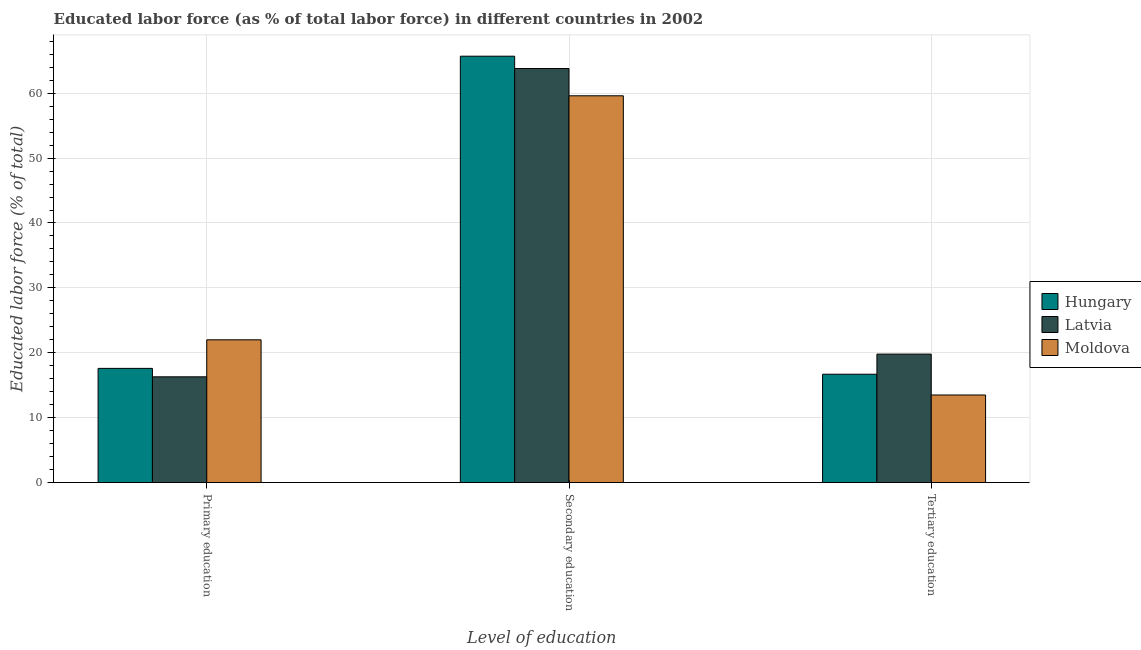Are the number of bars on each tick of the X-axis equal?
Ensure brevity in your answer.  Yes. How many bars are there on the 1st tick from the left?
Ensure brevity in your answer.  3. How many bars are there on the 1st tick from the right?
Ensure brevity in your answer.  3. What is the label of the 1st group of bars from the left?
Ensure brevity in your answer.  Primary education. What is the percentage of labor force who received primary education in Hungary?
Provide a short and direct response. 17.6. Across all countries, what is the maximum percentage of labor force who received secondary education?
Provide a short and direct response. 65.7. Across all countries, what is the minimum percentage of labor force who received secondary education?
Your answer should be very brief. 59.6. In which country was the percentage of labor force who received primary education maximum?
Keep it short and to the point. Moldova. In which country was the percentage of labor force who received primary education minimum?
Offer a very short reply. Latvia. What is the total percentage of labor force who received primary education in the graph?
Provide a succinct answer. 55.9. What is the difference between the percentage of labor force who received secondary education in Latvia and that in Hungary?
Offer a very short reply. -1.9. What is the difference between the percentage of labor force who received secondary education in Latvia and the percentage of labor force who received primary education in Moldova?
Give a very brief answer. 41.8. What is the average percentage of labor force who received primary education per country?
Your answer should be very brief. 18.63. What is the difference between the percentage of labor force who received primary education and percentage of labor force who received secondary education in Hungary?
Provide a short and direct response. -48.1. What is the ratio of the percentage of labor force who received secondary education in Hungary to that in Latvia?
Provide a short and direct response. 1.03. Is the percentage of labor force who received secondary education in Latvia less than that in Hungary?
Offer a terse response. Yes. What is the difference between the highest and the second highest percentage of labor force who received tertiary education?
Your response must be concise. 3.1. What is the difference between the highest and the lowest percentage of labor force who received tertiary education?
Give a very brief answer. 6.3. In how many countries, is the percentage of labor force who received secondary education greater than the average percentage of labor force who received secondary education taken over all countries?
Make the answer very short. 2. What does the 1st bar from the left in Tertiary education represents?
Offer a terse response. Hungary. What does the 1st bar from the right in Secondary education represents?
Make the answer very short. Moldova. How many bars are there?
Provide a succinct answer. 9. Are all the bars in the graph horizontal?
Your answer should be very brief. No. What is the difference between two consecutive major ticks on the Y-axis?
Make the answer very short. 10. Does the graph contain any zero values?
Your answer should be very brief. No. Where does the legend appear in the graph?
Your answer should be very brief. Center right. How are the legend labels stacked?
Your response must be concise. Vertical. What is the title of the graph?
Offer a terse response. Educated labor force (as % of total labor force) in different countries in 2002. Does "Japan" appear as one of the legend labels in the graph?
Your answer should be compact. No. What is the label or title of the X-axis?
Ensure brevity in your answer.  Level of education. What is the label or title of the Y-axis?
Ensure brevity in your answer.  Educated labor force (% of total). What is the Educated labor force (% of total) of Hungary in Primary education?
Offer a very short reply. 17.6. What is the Educated labor force (% of total) in Latvia in Primary education?
Your response must be concise. 16.3. What is the Educated labor force (% of total) in Hungary in Secondary education?
Offer a terse response. 65.7. What is the Educated labor force (% of total) in Latvia in Secondary education?
Your answer should be compact. 63.8. What is the Educated labor force (% of total) in Moldova in Secondary education?
Keep it short and to the point. 59.6. What is the Educated labor force (% of total) in Hungary in Tertiary education?
Offer a terse response. 16.7. What is the Educated labor force (% of total) in Latvia in Tertiary education?
Provide a succinct answer. 19.8. Across all Level of education, what is the maximum Educated labor force (% of total) in Hungary?
Provide a succinct answer. 65.7. Across all Level of education, what is the maximum Educated labor force (% of total) of Latvia?
Your response must be concise. 63.8. Across all Level of education, what is the maximum Educated labor force (% of total) in Moldova?
Ensure brevity in your answer.  59.6. Across all Level of education, what is the minimum Educated labor force (% of total) of Hungary?
Your answer should be compact. 16.7. Across all Level of education, what is the minimum Educated labor force (% of total) of Latvia?
Provide a short and direct response. 16.3. Across all Level of education, what is the minimum Educated labor force (% of total) of Moldova?
Offer a very short reply. 13.5. What is the total Educated labor force (% of total) in Hungary in the graph?
Your response must be concise. 100. What is the total Educated labor force (% of total) in Latvia in the graph?
Your response must be concise. 99.9. What is the total Educated labor force (% of total) in Moldova in the graph?
Provide a succinct answer. 95.1. What is the difference between the Educated labor force (% of total) of Hungary in Primary education and that in Secondary education?
Your response must be concise. -48.1. What is the difference between the Educated labor force (% of total) in Latvia in Primary education and that in Secondary education?
Your answer should be very brief. -47.5. What is the difference between the Educated labor force (% of total) in Moldova in Primary education and that in Secondary education?
Provide a succinct answer. -37.6. What is the difference between the Educated labor force (% of total) of Moldova in Primary education and that in Tertiary education?
Provide a short and direct response. 8.5. What is the difference between the Educated labor force (% of total) in Moldova in Secondary education and that in Tertiary education?
Provide a short and direct response. 46.1. What is the difference between the Educated labor force (% of total) in Hungary in Primary education and the Educated labor force (% of total) in Latvia in Secondary education?
Your response must be concise. -46.2. What is the difference between the Educated labor force (% of total) in Hungary in Primary education and the Educated labor force (% of total) in Moldova in Secondary education?
Make the answer very short. -42. What is the difference between the Educated labor force (% of total) of Latvia in Primary education and the Educated labor force (% of total) of Moldova in Secondary education?
Give a very brief answer. -43.3. What is the difference between the Educated labor force (% of total) of Hungary in Primary education and the Educated labor force (% of total) of Moldova in Tertiary education?
Ensure brevity in your answer.  4.1. What is the difference between the Educated labor force (% of total) of Latvia in Primary education and the Educated labor force (% of total) of Moldova in Tertiary education?
Your response must be concise. 2.8. What is the difference between the Educated labor force (% of total) of Hungary in Secondary education and the Educated labor force (% of total) of Latvia in Tertiary education?
Offer a terse response. 45.9. What is the difference between the Educated labor force (% of total) in Hungary in Secondary education and the Educated labor force (% of total) in Moldova in Tertiary education?
Offer a terse response. 52.2. What is the difference between the Educated labor force (% of total) of Latvia in Secondary education and the Educated labor force (% of total) of Moldova in Tertiary education?
Give a very brief answer. 50.3. What is the average Educated labor force (% of total) of Hungary per Level of education?
Provide a short and direct response. 33.33. What is the average Educated labor force (% of total) of Latvia per Level of education?
Your answer should be very brief. 33.3. What is the average Educated labor force (% of total) in Moldova per Level of education?
Give a very brief answer. 31.7. What is the difference between the Educated labor force (% of total) in Hungary and Educated labor force (% of total) in Moldova in Primary education?
Your answer should be compact. -4.4. What is the difference between the Educated labor force (% of total) in Latvia and Educated labor force (% of total) in Moldova in Primary education?
Provide a short and direct response. -5.7. What is the difference between the Educated labor force (% of total) in Hungary and Educated labor force (% of total) in Moldova in Secondary education?
Your answer should be very brief. 6.1. What is the difference between the Educated labor force (% of total) in Latvia and Educated labor force (% of total) in Moldova in Secondary education?
Keep it short and to the point. 4.2. What is the difference between the Educated labor force (% of total) of Hungary and Educated labor force (% of total) of Moldova in Tertiary education?
Your response must be concise. 3.2. What is the difference between the Educated labor force (% of total) of Latvia and Educated labor force (% of total) of Moldova in Tertiary education?
Provide a short and direct response. 6.3. What is the ratio of the Educated labor force (% of total) in Hungary in Primary education to that in Secondary education?
Offer a very short reply. 0.27. What is the ratio of the Educated labor force (% of total) of Latvia in Primary education to that in Secondary education?
Keep it short and to the point. 0.26. What is the ratio of the Educated labor force (% of total) of Moldova in Primary education to that in Secondary education?
Offer a very short reply. 0.37. What is the ratio of the Educated labor force (% of total) of Hungary in Primary education to that in Tertiary education?
Offer a terse response. 1.05. What is the ratio of the Educated labor force (% of total) in Latvia in Primary education to that in Tertiary education?
Offer a terse response. 0.82. What is the ratio of the Educated labor force (% of total) of Moldova in Primary education to that in Tertiary education?
Your response must be concise. 1.63. What is the ratio of the Educated labor force (% of total) of Hungary in Secondary education to that in Tertiary education?
Keep it short and to the point. 3.93. What is the ratio of the Educated labor force (% of total) in Latvia in Secondary education to that in Tertiary education?
Make the answer very short. 3.22. What is the ratio of the Educated labor force (% of total) in Moldova in Secondary education to that in Tertiary education?
Your response must be concise. 4.41. What is the difference between the highest and the second highest Educated labor force (% of total) in Hungary?
Offer a terse response. 48.1. What is the difference between the highest and the second highest Educated labor force (% of total) of Latvia?
Ensure brevity in your answer.  44. What is the difference between the highest and the second highest Educated labor force (% of total) in Moldova?
Make the answer very short. 37.6. What is the difference between the highest and the lowest Educated labor force (% of total) in Latvia?
Provide a succinct answer. 47.5. What is the difference between the highest and the lowest Educated labor force (% of total) of Moldova?
Keep it short and to the point. 46.1. 